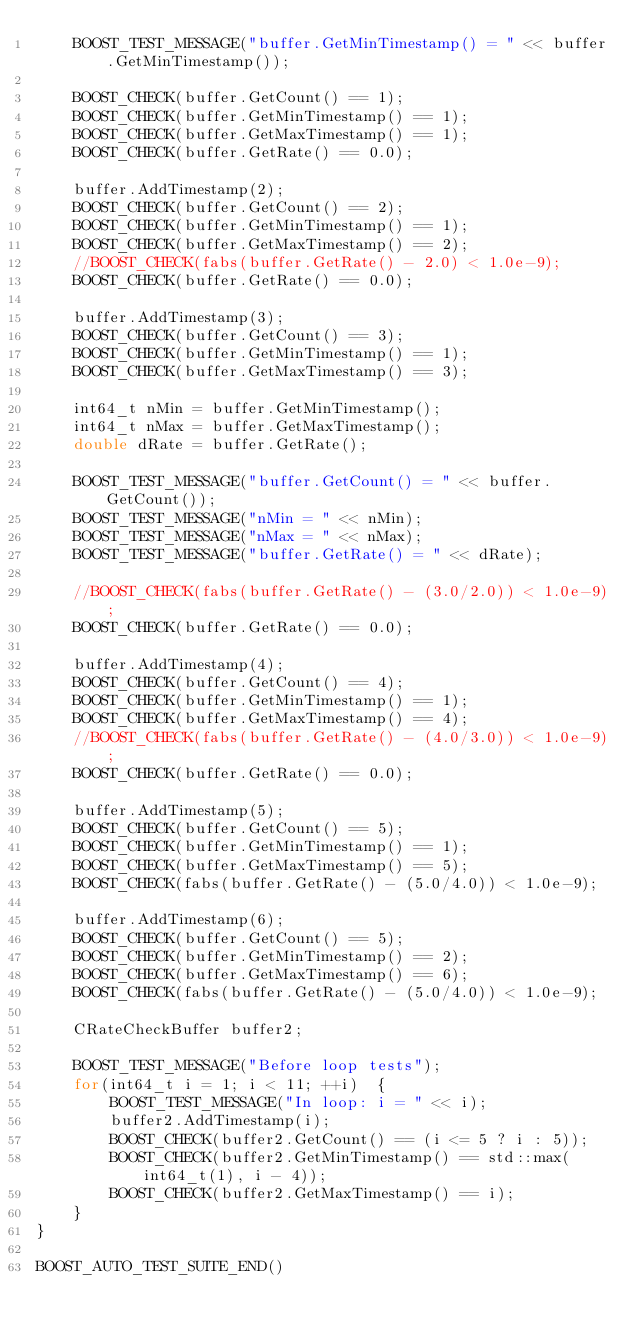<code> <loc_0><loc_0><loc_500><loc_500><_C++_>    BOOST_TEST_MESSAGE("buffer.GetMinTimestamp() = " << buffer.GetMinTimestamp());

    BOOST_CHECK(buffer.GetCount() == 1);
    BOOST_CHECK(buffer.GetMinTimestamp() == 1);
    BOOST_CHECK(buffer.GetMaxTimestamp() == 1);
    BOOST_CHECK(buffer.GetRate() == 0.0);

    buffer.AddTimestamp(2);
    BOOST_CHECK(buffer.GetCount() == 2);
    BOOST_CHECK(buffer.GetMinTimestamp() == 1);
    BOOST_CHECK(buffer.GetMaxTimestamp() == 2);
    //BOOST_CHECK(fabs(buffer.GetRate() - 2.0) < 1.0e-9);
    BOOST_CHECK(buffer.GetRate() == 0.0);

    buffer.AddTimestamp(3);
    BOOST_CHECK(buffer.GetCount() == 3);
    BOOST_CHECK(buffer.GetMinTimestamp() == 1);
    BOOST_CHECK(buffer.GetMaxTimestamp() == 3);

    int64_t nMin = buffer.GetMinTimestamp();
    int64_t nMax = buffer.GetMaxTimestamp();
    double dRate = buffer.GetRate();

    BOOST_TEST_MESSAGE("buffer.GetCount() = " << buffer.GetCount());
    BOOST_TEST_MESSAGE("nMin = " << nMin);
    BOOST_TEST_MESSAGE("nMax = " << nMax);
    BOOST_TEST_MESSAGE("buffer.GetRate() = " << dRate);

    //BOOST_CHECK(fabs(buffer.GetRate() - (3.0/2.0)) < 1.0e-9);
    BOOST_CHECK(buffer.GetRate() == 0.0);

    buffer.AddTimestamp(4);
    BOOST_CHECK(buffer.GetCount() == 4);
    BOOST_CHECK(buffer.GetMinTimestamp() == 1);
    BOOST_CHECK(buffer.GetMaxTimestamp() == 4);
    //BOOST_CHECK(fabs(buffer.GetRate() - (4.0/3.0)) < 1.0e-9);
    BOOST_CHECK(buffer.GetRate() == 0.0);

    buffer.AddTimestamp(5);
    BOOST_CHECK(buffer.GetCount() == 5);
    BOOST_CHECK(buffer.GetMinTimestamp() == 1);
    BOOST_CHECK(buffer.GetMaxTimestamp() == 5);
    BOOST_CHECK(fabs(buffer.GetRate() - (5.0/4.0)) < 1.0e-9);

    buffer.AddTimestamp(6);
    BOOST_CHECK(buffer.GetCount() == 5);
    BOOST_CHECK(buffer.GetMinTimestamp() == 2);
    BOOST_CHECK(buffer.GetMaxTimestamp() == 6);
    BOOST_CHECK(fabs(buffer.GetRate() - (5.0/4.0)) < 1.0e-9);

    CRateCheckBuffer buffer2;

    BOOST_TEST_MESSAGE("Before loop tests");
    for(int64_t i = 1; i < 11; ++i)  {
        BOOST_TEST_MESSAGE("In loop: i = " << i);
        buffer2.AddTimestamp(i);
        BOOST_CHECK(buffer2.GetCount() == (i <= 5 ? i : 5));
        BOOST_CHECK(buffer2.GetMinTimestamp() == std::max(int64_t(1), i - 4));
        BOOST_CHECK(buffer2.GetMaxTimestamp() == i);
    }
}

BOOST_AUTO_TEST_SUITE_END()
</code> 